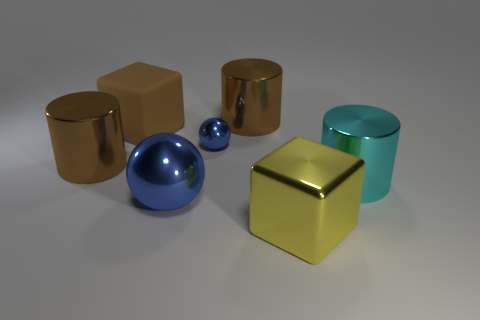Add 3 large blue metallic spheres. How many objects exist? 10 Subtract all spheres. How many objects are left? 5 Subtract all brown objects. Subtract all blue metal things. How many objects are left? 2 Add 2 big brown rubber blocks. How many big brown rubber blocks are left? 3 Add 1 large blue things. How many large blue things exist? 2 Subtract 0 red spheres. How many objects are left? 7 